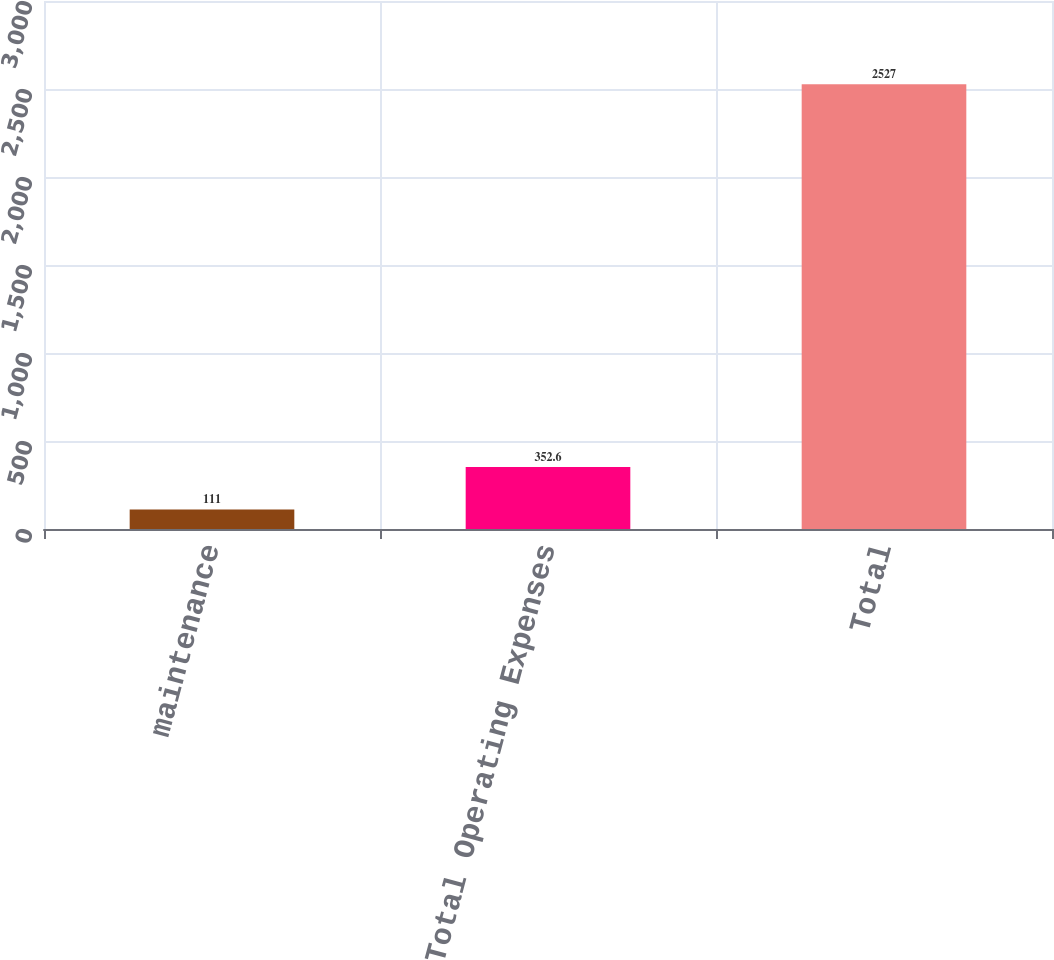<chart> <loc_0><loc_0><loc_500><loc_500><bar_chart><fcel>maintenance<fcel>Total Operating Expenses<fcel>Total<nl><fcel>111<fcel>352.6<fcel>2527<nl></chart> 